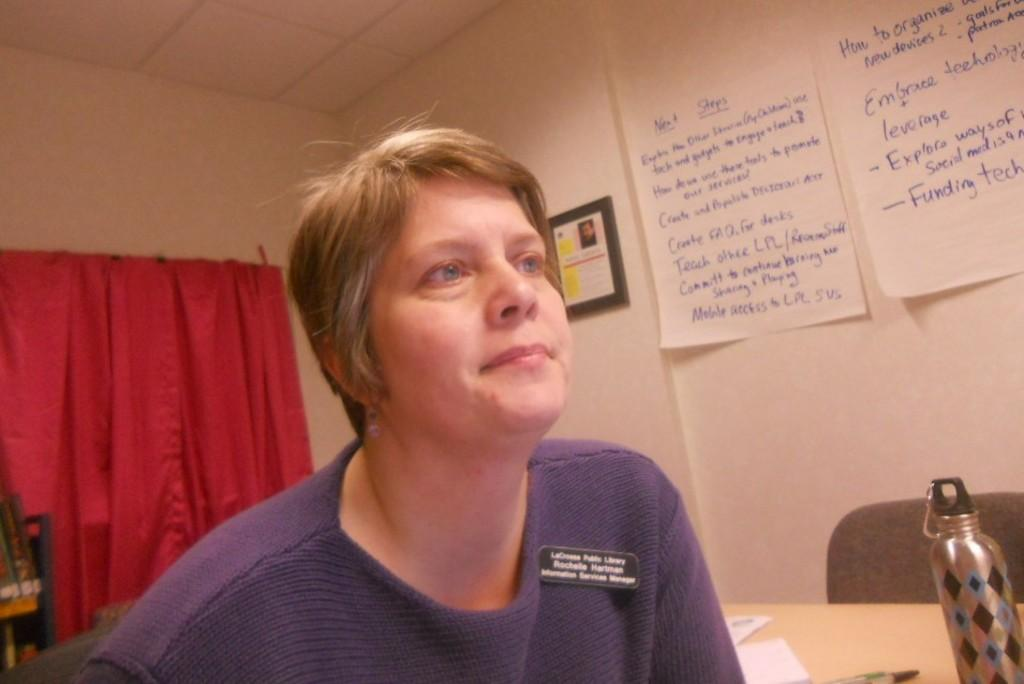Who is the main subject in the image? There is a woman in the image. What is the woman doing in the image? The woman is looking to the right side. What is the woman wearing in the image? The woman is wearing a sweater. What can be seen on the left side of the image? There is a curtain on the left side of the image. What object is present on a table in the image? There is a water bottle on a table in the image. What type of pleasure does the woman experience while looking to the right side in the image? There is no indication of pleasure or any emotional state in the image; the woman is simply looking to the right side. 